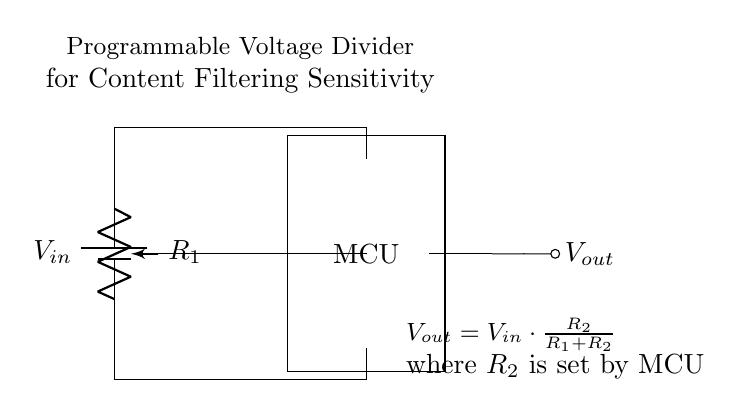What is the input voltage represented in the circuit? The input voltage is labeled as V in, which is positioned at the top of the circuit diagram connected to the battery symbol.
Answer: V in What type of component is R1 in this circuit? R1 is shown as a potentiometer, indicated by the pR label and drawn with a wiper symbol, allowing for variable resistance.
Answer: Potentiometer What role does the microcontroller play in this circuit? The microcontroller (MCU) is responsible for adjusting the resistance R2, which impacts the output voltage based on the setting chosen.
Answer: Adjusting R2 What is the output voltage formula depicted in the diagram? The formula for the output voltage V out is shown beneath the circuit, stating that V out equals V in multiplied by R2 divided by the sum of R1 and R2.
Answer: V out = V in * (R2 / (R1 + R2)) How is the potentiometer connected in the circuit? The potentiometer is connected in parallel to the input voltage and then linked to the microcontroller, allowing for adjustable voltage division for the output path.
Answer: Parallel connection Which component provides the output voltage? The output voltage is taken from the connection at the wiper of the potentiometer leading to the microcontroller, indicated as V out in the circuit.
Answer: Potentiometer 